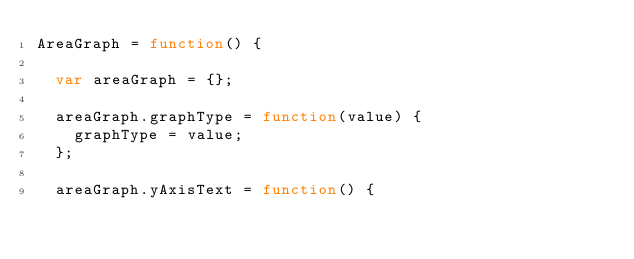Convert code to text. <code><loc_0><loc_0><loc_500><loc_500><_JavaScript_>AreaGraph = function() {

  var areaGraph = {};

  areaGraph.graphType = function(value) {
    graphType = value;
  };

  areaGraph.yAxisText = function() {</code> 